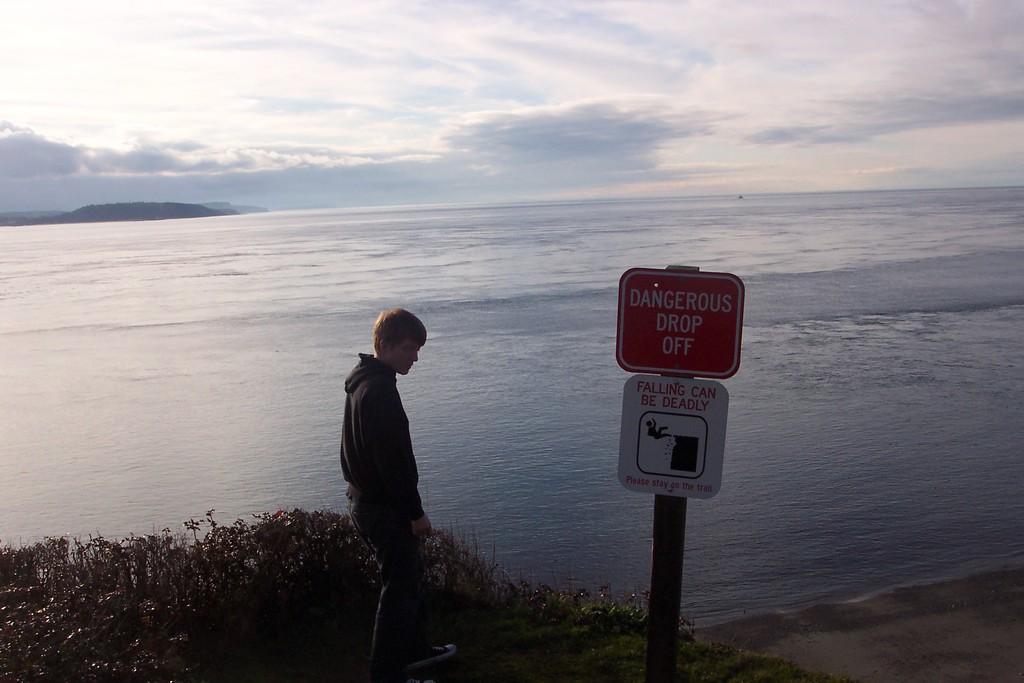How would you summarize this image in a sentence or two? At the bottom I can see a man is standing on the ground. Around this man I can see some plants. On the the right side of this man I can see a pole to which two boards are attached. On the boards I can see some text. In the middle of the image there is a sea. On the top of the image I can see the sky and the clouds 